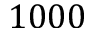<formula> <loc_0><loc_0><loc_500><loc_500>1 0 0 0</formula> 